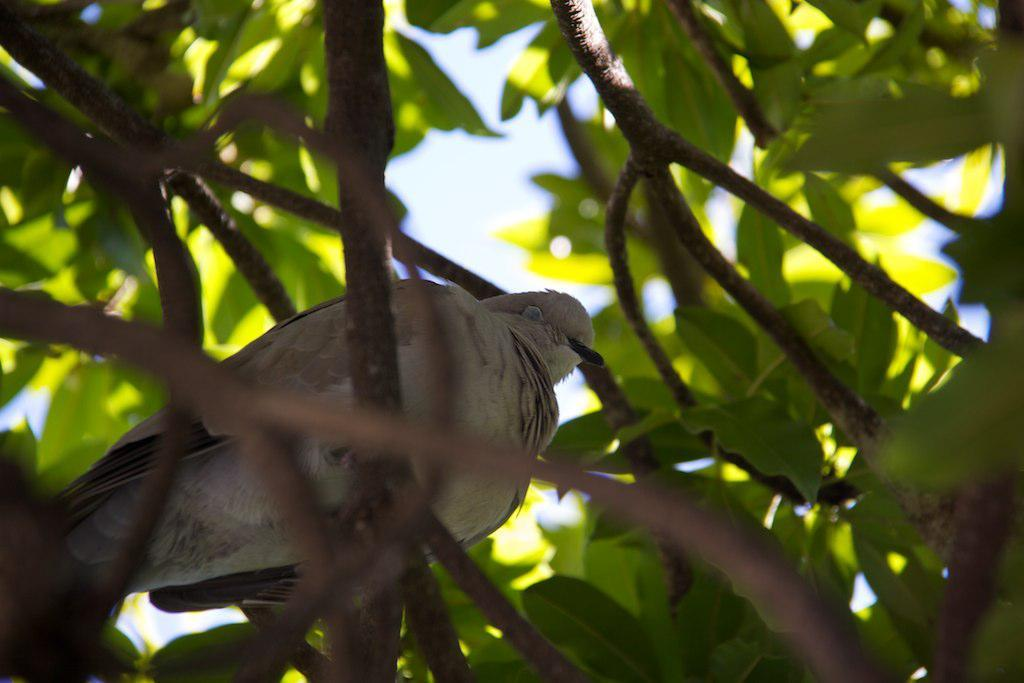What type of animal can be seen in the image? There is a bird in the image. Where is the bird located in the image? The bird is sitting on a branch. What is the branch a part of? The branch is part of a tree. What can be seen in the background of the image? There are branches and leaves visible in the background of the image. Is there a cave visible in the image? No, there is no cave present in the image. Can you see any farm animals in the image? No, there are no farm animals visible in the image; it features a bird sitting on a branch. 